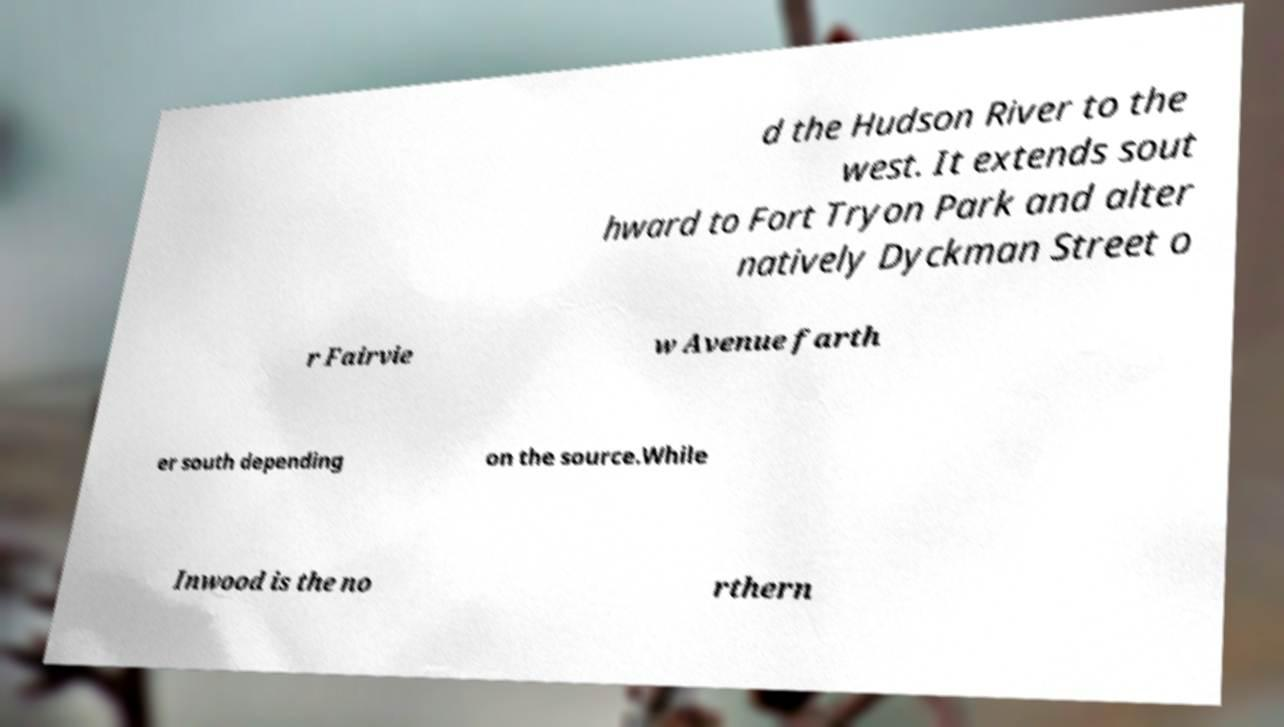Could you extract and type out the text from this image? d the Hudson River to the west. It extends sout hward to Fort Tryon Park and alter natively Dyckman Street o r Fairvie w Avenue farth er south depending on the source.While Inwood is the no rthern 